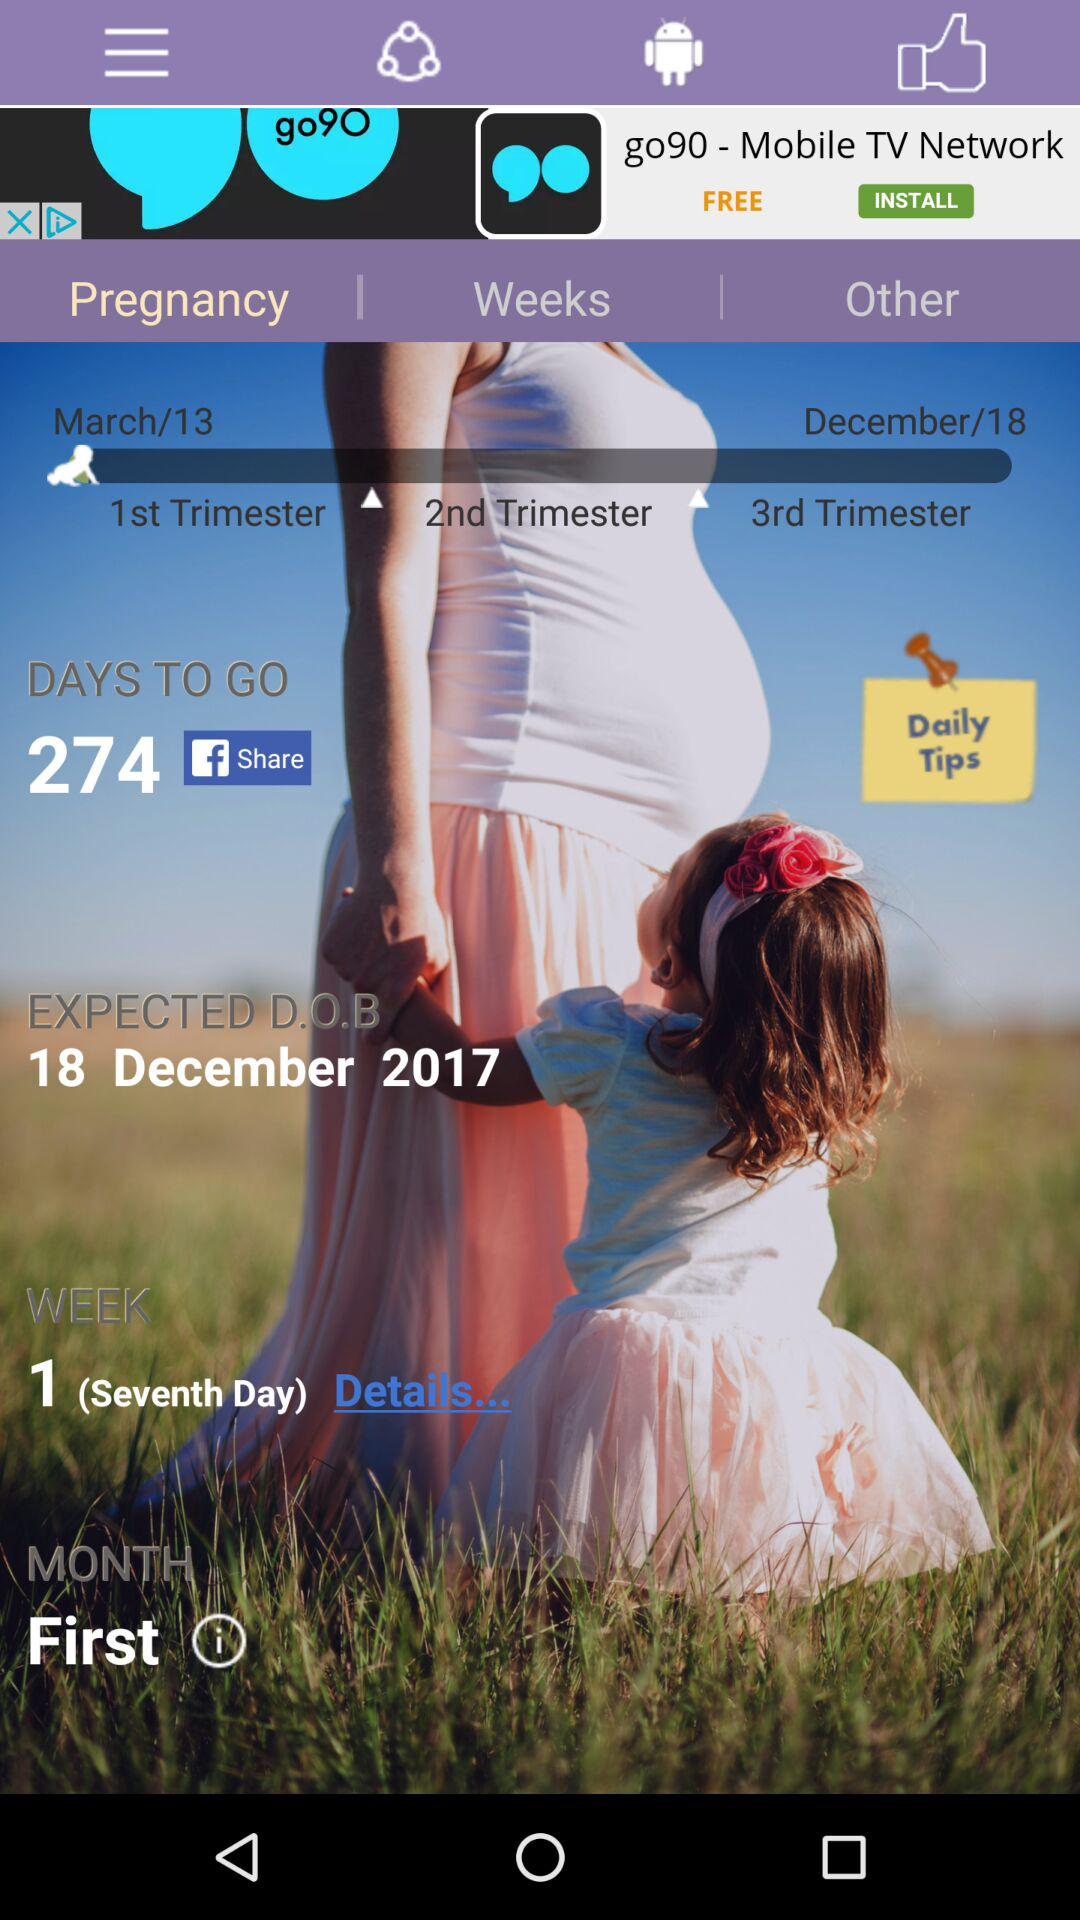What month is going on? The month that is going on is the first. 